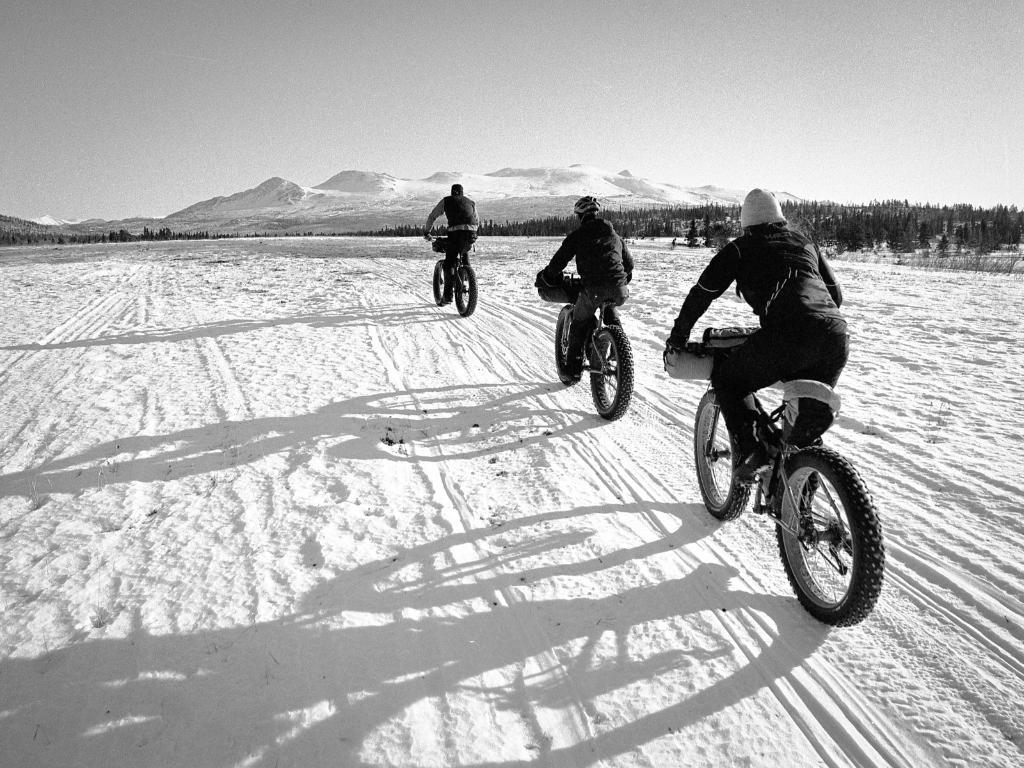How many people are in the image? There are three people in the image. What are the people doing in the image? The people are cycling their cycles. What can be seen in the background of the image? There are trees and mountains in the background of the image. What news is being broadcasted from the jail in the image? There is no jail or news broadcast present in the image. 